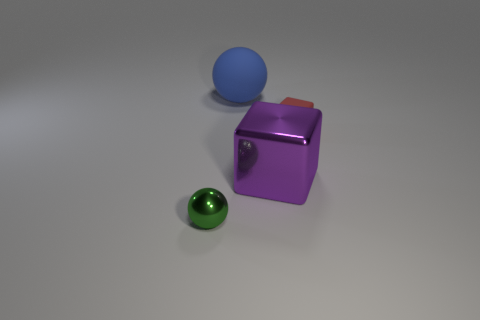Add 4 cyan shiny cylinders. How many objects exist? 8 Subtract all purple blocks. How many blocks are left? 1 Subtract all blue blocks. Subtract all brown cylinders. How many blocks are left? 2 Subtract 1 balls. How many balls are left? 1 Subtract all purple metallic cubes. Subtract all tiny yellow shiny objects. How many objects are left? 3 Add 1 tiny things. How many tiny things are left? 3 Add 2 large blue rubber spheres. How many large blue rubber spheres exist? 3 Subtract 1 purple blocks. How many objects are left? 3 